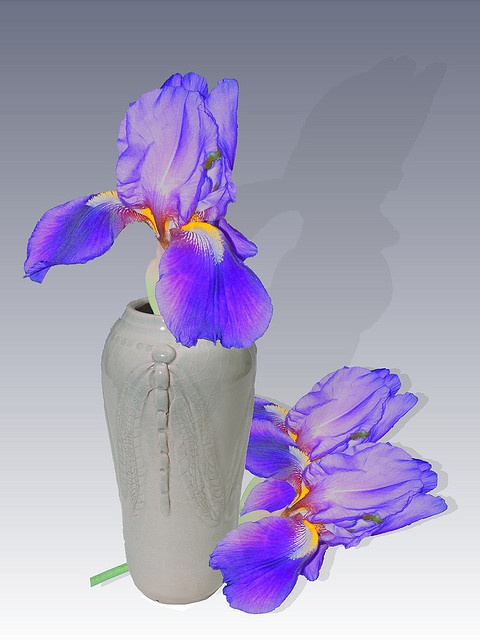Describe the objects in this image and their specific colors. I can see a vase in gray, darkgray, and lightgray tones in this image. 